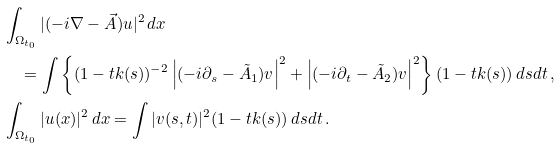Convert formula to latex. <formula><loc_0><loc_0><loc_500><loc_500>& \int _ { \Omega _ { t _ { 0 } } } | ( - i \nabla - \vec { A } ) u | ^ { 2 } \, d x \\ & \quad = \int \left \{ ( 1 - t k ( s ) ) ^ { - 2 } \left | ( - i \partial _ { s } - \tilde { A } _ { 1 } ) v \right | ^ { 2 } + \left | ( - i \partial _ { t } - \tilde { A } _ { 2 } ) v \right | ^ { 2 } \right \} ( 1 - t k ( s ) ) \, d s d t \, , \\ & \int _ { \Omega _ { t _ { 0 } } } | u ( x ) | ^ { 2 } \, d x = \int | v ( s , t ) | ^ { 2 } ( 1 - t k ( s ) ) \, d s d t \, .</formula> 